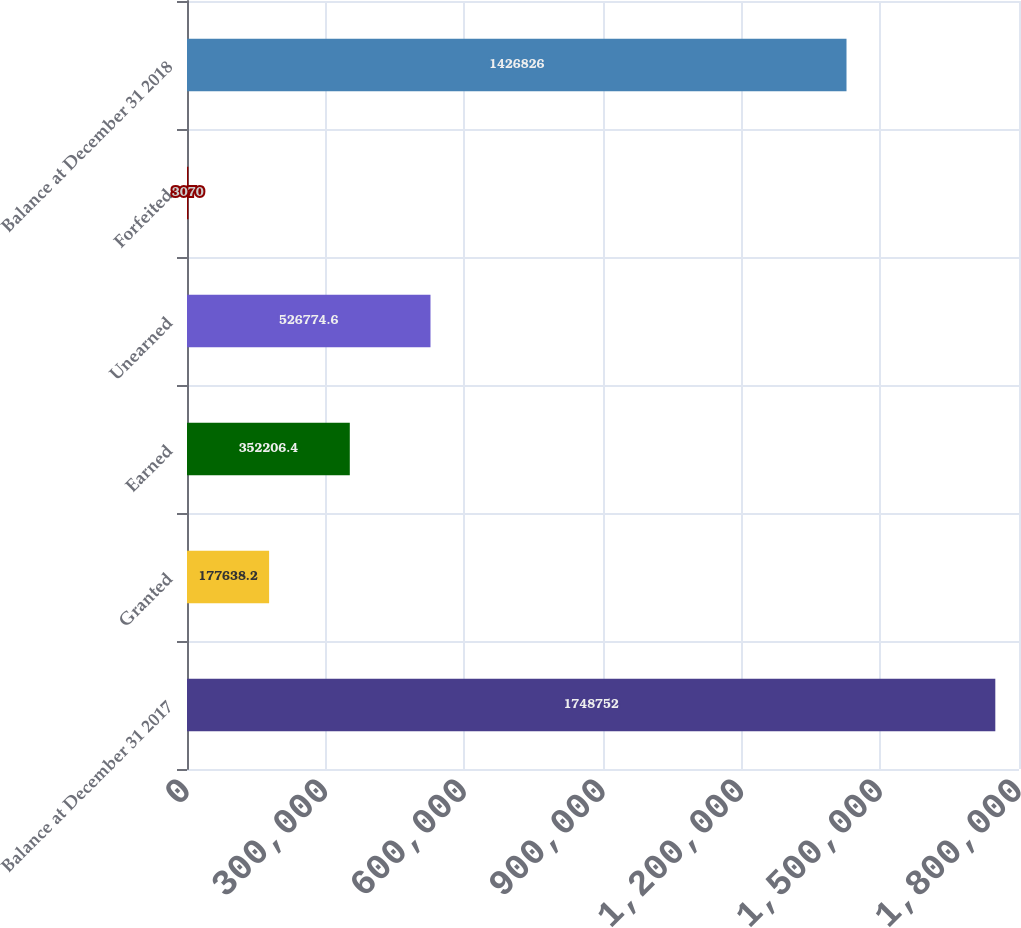Convert chart. <chart><loc_0><loc_0><loc_500><loc_500><bar_chart><fcel>Balance at December 31 2017<fcel>Granted<fcel>Earned<fcel>Unearned<fcel>Forfeited<fcel>Balance at December 31 2018<nl><fcel>1.74875e+06<fcel>177638<fcel>352206<fcel>526775<fcel>3070<fcel>1.42683e+06<nl></chart> 